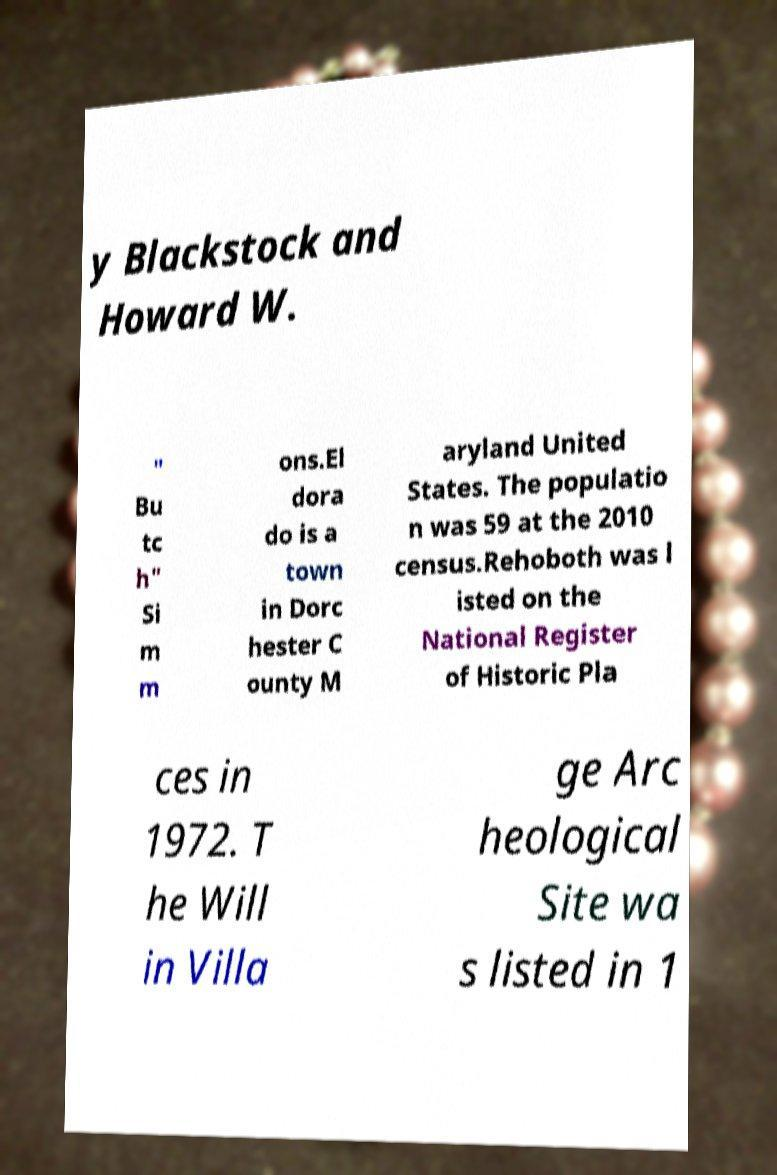What messages or text are displayed in this image? I need them in a readable, typed format. y Blackstock and Howard W. " Bu tc h" Si m m ons.El dora do is a town in Dorc hester C ounty M aryland United States. The populatio n was 59 at the 2010 census.Rehoboth was l isted on the National Register of Historic Pla ces in 1972. T he Will in Villa ge Arc heological Site wa s listed in 1 